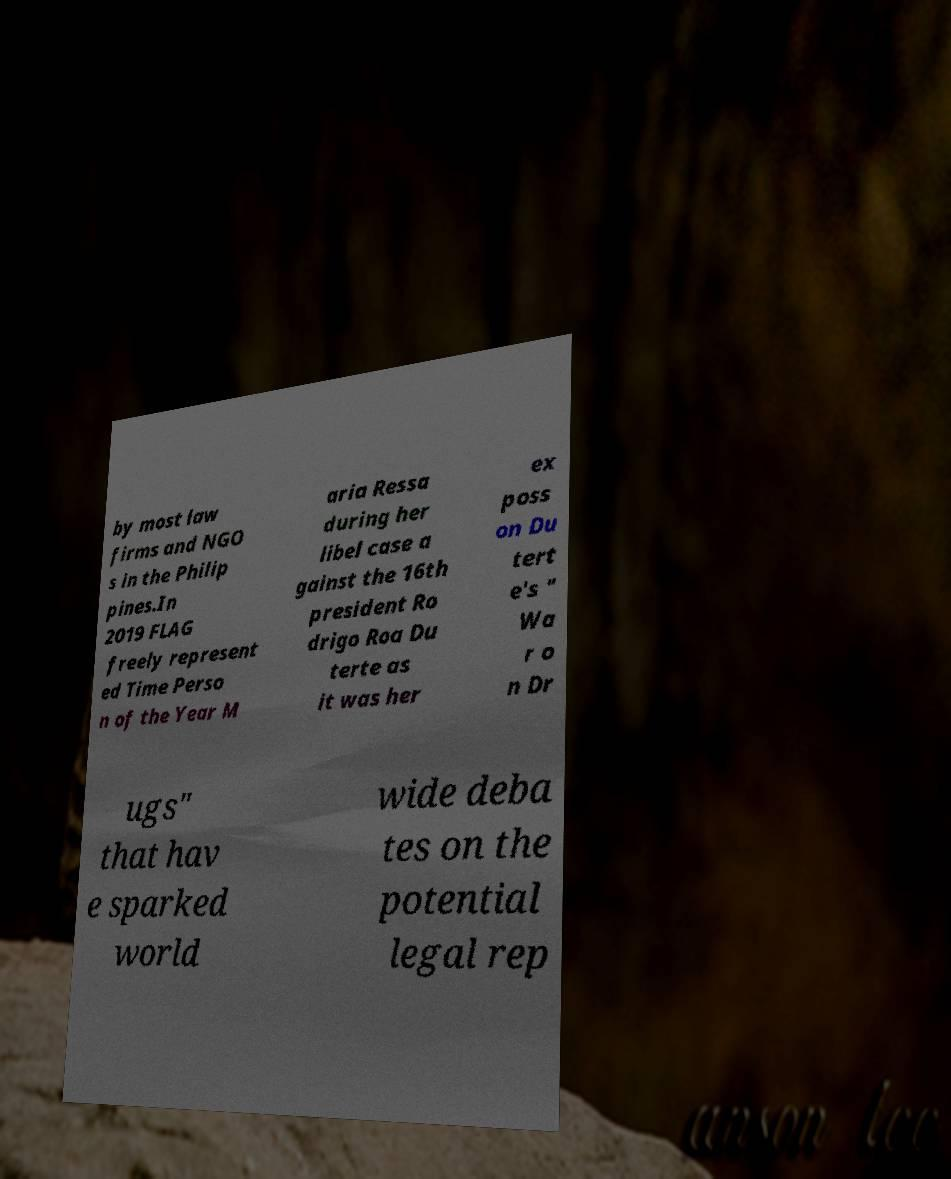Could you assist in decoding the text presented in this image and type it out clearly? by most law firms and NGO s in the Philip pines.In 2019 FLAG freely represent ed Time Perso n of the Year M aria Ressa during her libel case a gainst the 16th president Ro drigo Roa Du terte as it was her ex poss on Du tert e's " Wa r o n Dr ugs" that hav e sparked world wide deba tes on the potential legal rep 